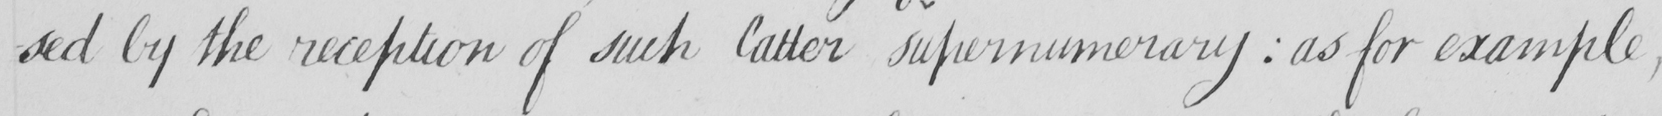What text is written in this handwritten line? -sed by the reception of such latter supernumerary  :  as for example , 